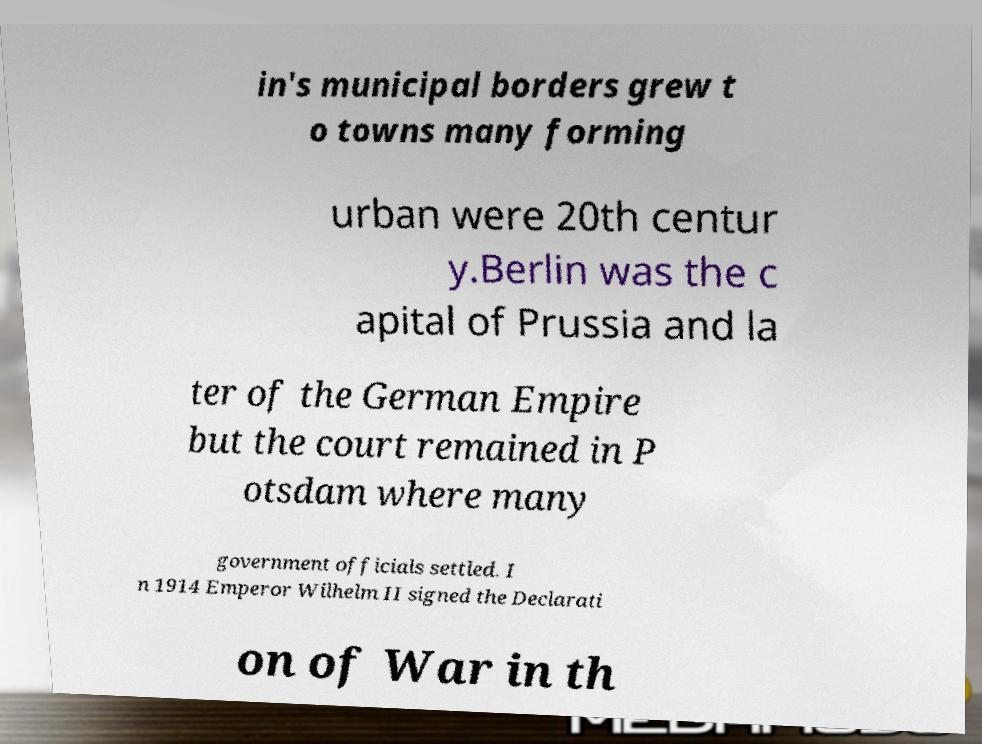For documentation purposes, I need the text within this image transcribed. Could you provide that? in's municipal borders grew t o towns many forming urban were 20th centur y.Berlin was the c apital of Prussia and la ter of the German Empire but the court remained in P otsdam where many government officials settled. I n 1914 Emperor Wilhelm II signed the Declarati on of War in th 